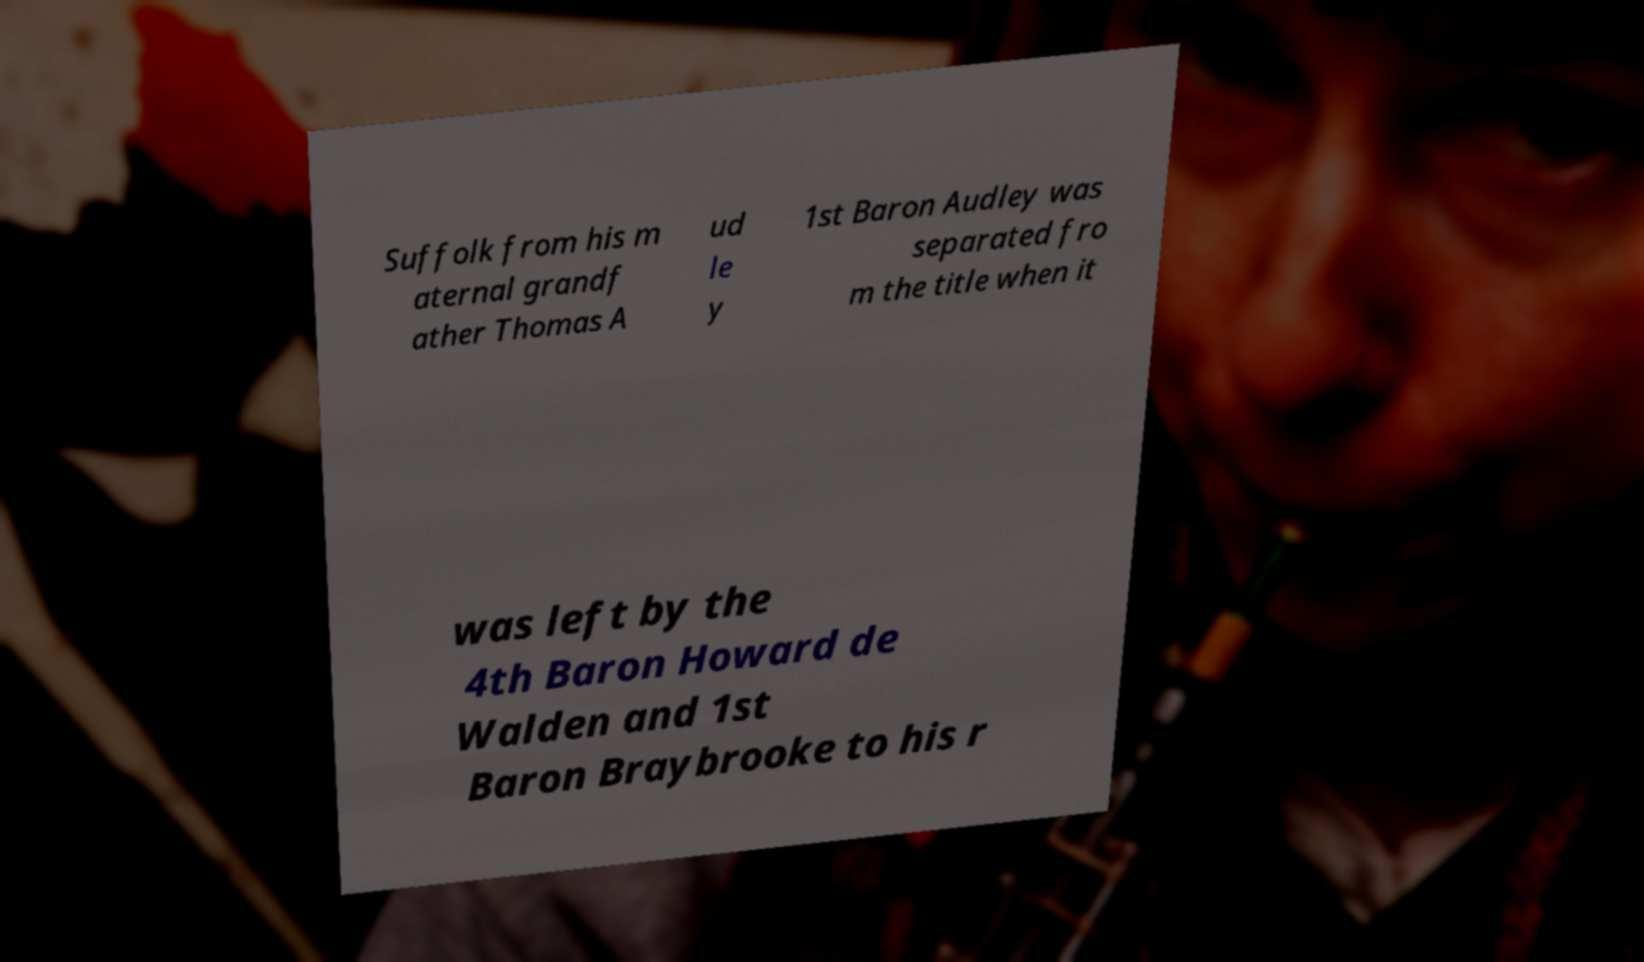Can you accurately transcribe the text from the provided image for me? Suffolk from his m aternal grandf ather Thomas A ud le y 1st Baron Audley was separated fro m the title when it was left by the 4th Baron Howard de Walden and 1st Baron Braybrooke to his r 